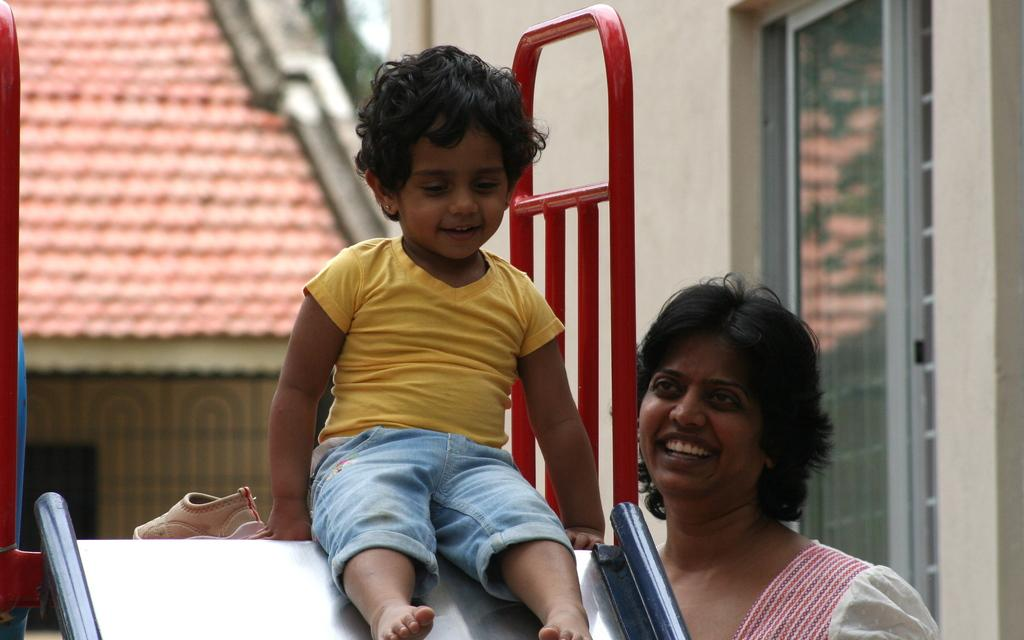What type of structures can be seen in the image? There are buildings in the image. Can you describe any specific feature of the buildings? There is a red color roof visible in the image. Are there any people present in the image? Yes, there are two people in the front of the image. How many fingers can be seen pointing at the word in the image? There is no word or finger pointing at it in the image. 